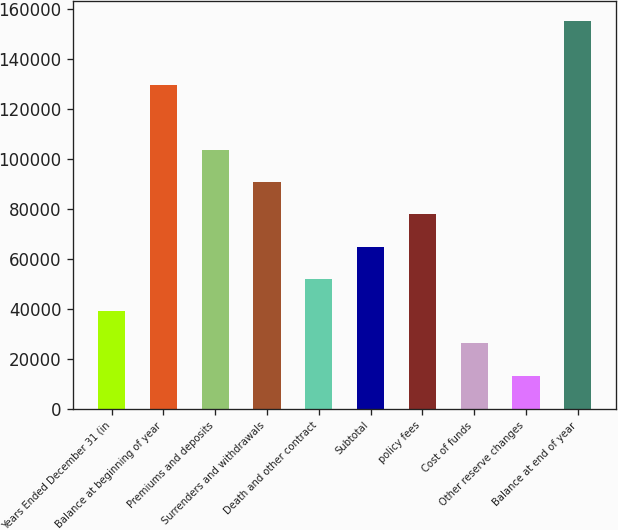Convert chart to OTSL. <chart><loc_0><loc_0><loc_500><loc_500><bar_chart><fcel>Years Ended December 31 (in<fcel>Balance at beginning of year<fcel>Premiums and deposits<fcel>Surrenders and withdrawals<fcel>Death and other contract<fcel>Subtotal<fcel>policy fees<fcel>Cost of funds<fcel>Other reserve changes<fcel>Balance at end of year<nl><fcel>39056<fcel>129321<fcel>103531<fcel>90636<fcel>51951<fcel>64846<fcel>77741<fcel>26161<fcel>13266<fcel>155111<nl></chart> 